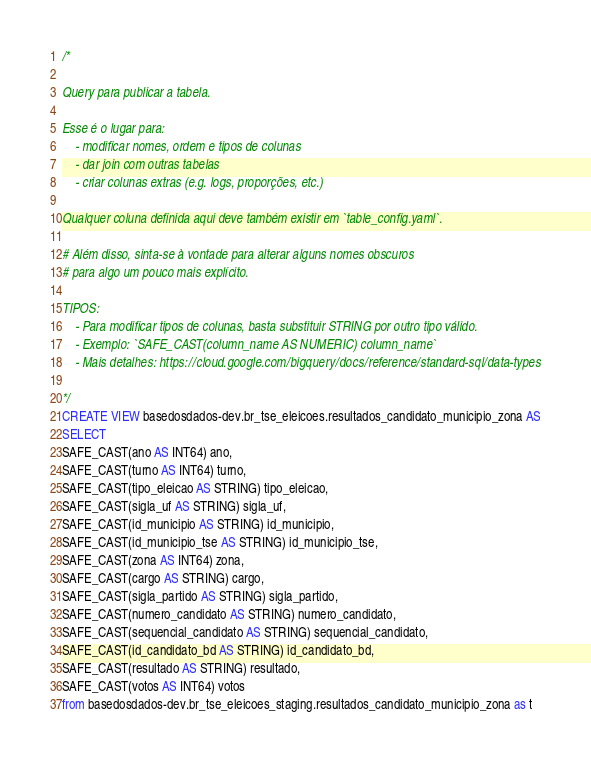<code> <loc_0><loc_0><loc_500><loc_500><_SQL_>/*

Query para publicar a tabela.

Esse é o lugar para:
    - modificar nomes, ordem e tipos de colunas
    - dar join com outras tabelas
    - criar colunas extras (e.g. logs, proporções, etc.)

Qualquer coluna definida aqui deve também existir em `table_config.yaml`.

# Além disso, sinta-se à vontade para alterar alguns nomes obscuros
# para algo um pouco mais explícito.

TIPOS:
    - Para modificar tipos de colunas, basta substituir STRING por outro tipo válido.
    - Exemplo: `SAFE_CAST(column_name AS NUMERIC) column_name`
    - Mais detalhes: https://cloud.google.com/bigquery/docs/reference/standard-sql/data-types

*/
CREATE VIEW basedosdados-dev.br_tse_eleicoes.resultados_candidato_municipio_zona AS
SELECT 
SAFE_CAST(ano AS INT64) ano,
SAFE_CAST(turno AS INT64) turno,
SAFE_CAST(tipo_eleicao AS STRING) tipo_eleicao,
SAFE_CAST(sigla_uf AS STRING) sigla_uf,
SAFE_CAST(id_municipio AS STRING) id_municipio,
SAFE_CAST(id_municipio_tse AS STRING) id_municipio_tse,
SAFE_CAST(zona AS INT64) zona,
SAFE_CAST(cargo AS STRING) cargo,
SAFE_CAST(sigla_partido AS STRING) sigla_partido,
SAFE_CAST(numero_candidato AS STRING) numero_candidato,
SAFE_CAST(sequencial_candidato AS STRING) sequencial_candidato,
SAFE_CAST(id_candidato_bd AS STRING) id_candidato_bd,
SAFE_CAST(resultado AS STRING) resultado,
SAFE_CAST(votos AS INT64) votos
from basedosdados-dev.br_tse_eleicoes_staging.resultados_candidato_municipio_zona as t</code> 